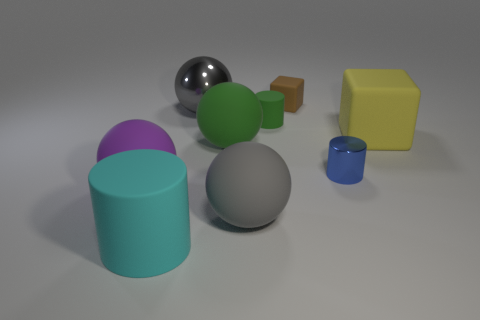Do the matte block that is to the right of the blue object and the gray rubber ball have the same size?
Your answer should be very brief. Yes. Does the shiny thing that is left of the large green rubber object have the same shape as the tiny brown object?
Provide a succinct answer. No. How many objects are either blue matte cylinders or matte cylinders that are behind the cyan matte cylinder?
Give a very brief answer. 1. Are there fewer brown cubes than big shiny blocks?
Provide a succinct answer. No. Are there more big rubber balls than big things?
Make the answer very short. No. What number of other things are there of the same material as the green ball
Ensure brevity in your answer.  6. How many big purple objects are to the right of the big thing that is in front of the gray object in front of the small green cylinder?
Provide a succinct answer. 0. What number of matte things are either big gray balls or tiny green cylinders?
Provide a short and direct response. 2. There is a matte cylinder that is behind the matte cylinder in front of the big green object; what is its size?
Offer a terse response. Small. Does the big ball that is right of the large green ball have the same color as the metallic object that is behind the small green matte cylinder?
Give a very brief answer. Yes. 